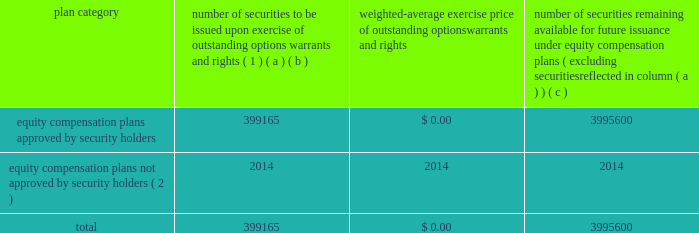Equity compensation plan information the table presents the equity securities available for issuance under our equity compensation plans as of december 31 , 2018 .
Equity compensation plan information plan category number of securities to be issued upon exercise of outstanding options , warrants and rights ( 1 ) weighted-average exercise price of outstanding options , warrants and rights number of securities remaining available for future issuance under equity compensation plans ( excluding securities reflected in column ( a ) ) ( a ) ( b ) ( c ) equity compensation plans approved by security holders 399165 $ 0.00 3995600 equity compensation plans not approved by security holders ( 2 ) 2014 2014 2014 .
( 1 ) includes grants made under the huntington ingalls industries , inc .
2012 long-term incentive stock plan ( the "2012 plan" ) , which was approved by our stockholders on may 2 , 2012 , and the huntington ingalls industries , inc .
2011 long-term incentive stock plan ( the "2011 plan" ) , which was approved by the sole stockholder of hii prior to its spin-off from northrop grumman corporation .
Of these shares , 27123 were stock rights granted under the 2011 plan .
In addition , this number includes 31697 stock rights , 5051 restricted stock rights , and 335293 restricted performance stock rights granted under the 2012 plan , assuming target performance achievement .
( 2 ) there are no awards made under plans not approved by security holders .
Item 13 .
Certain relationships and related transactions , and director independence information as to certain relationships and related transactions and director independence will be incorporated herein by reference to the proxy statement for our 2019 annual meeting of stockholders , to be filed within 120 days after the end of the company 2019s fiscal year .
Item 14 .
Principal accountant fees and services information as to principal accountant fees and services will be incorporated herein by reference to the proxy statement for our 2019 annual meeting of stockholders , to be filed within 120 days after the end of the company 2019s fiscal year. .
What portion of the equity compensation plan approved by security holders is to be issued upon the exercise of the outstanding options warrants and rights? 
Computations: (399165 / (399165 + 3995600))
Answer: 0.09083. 